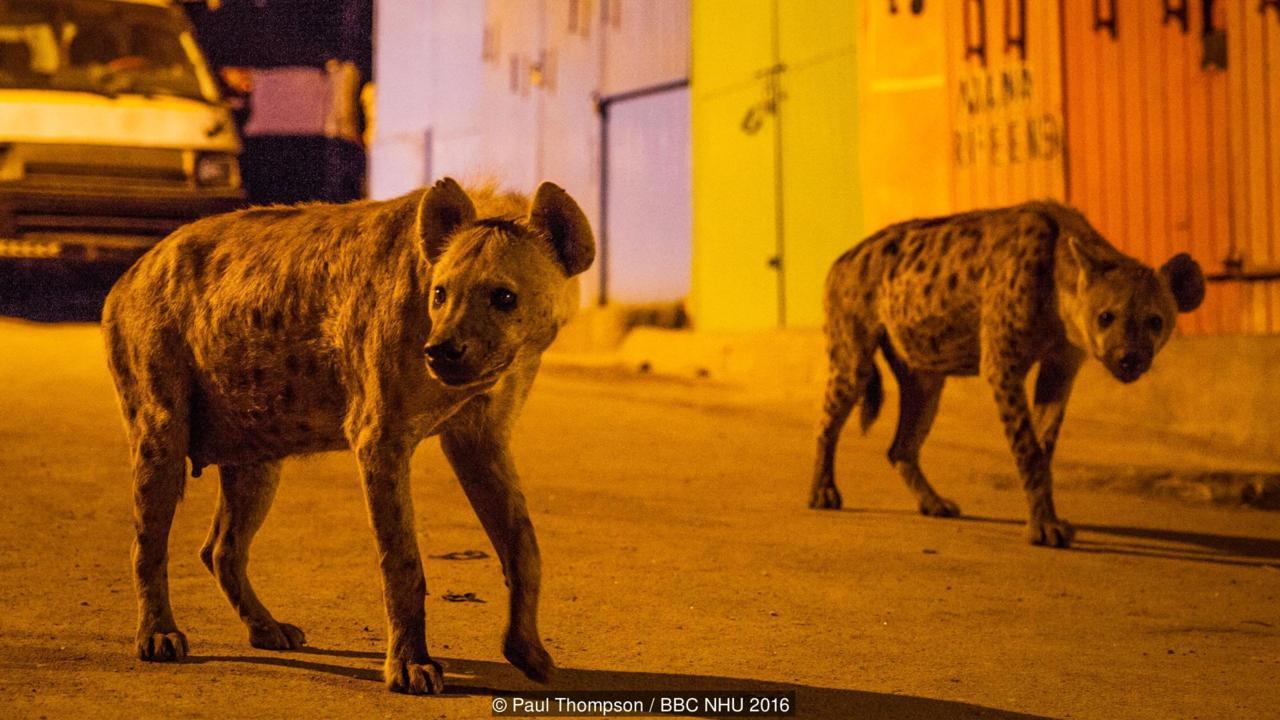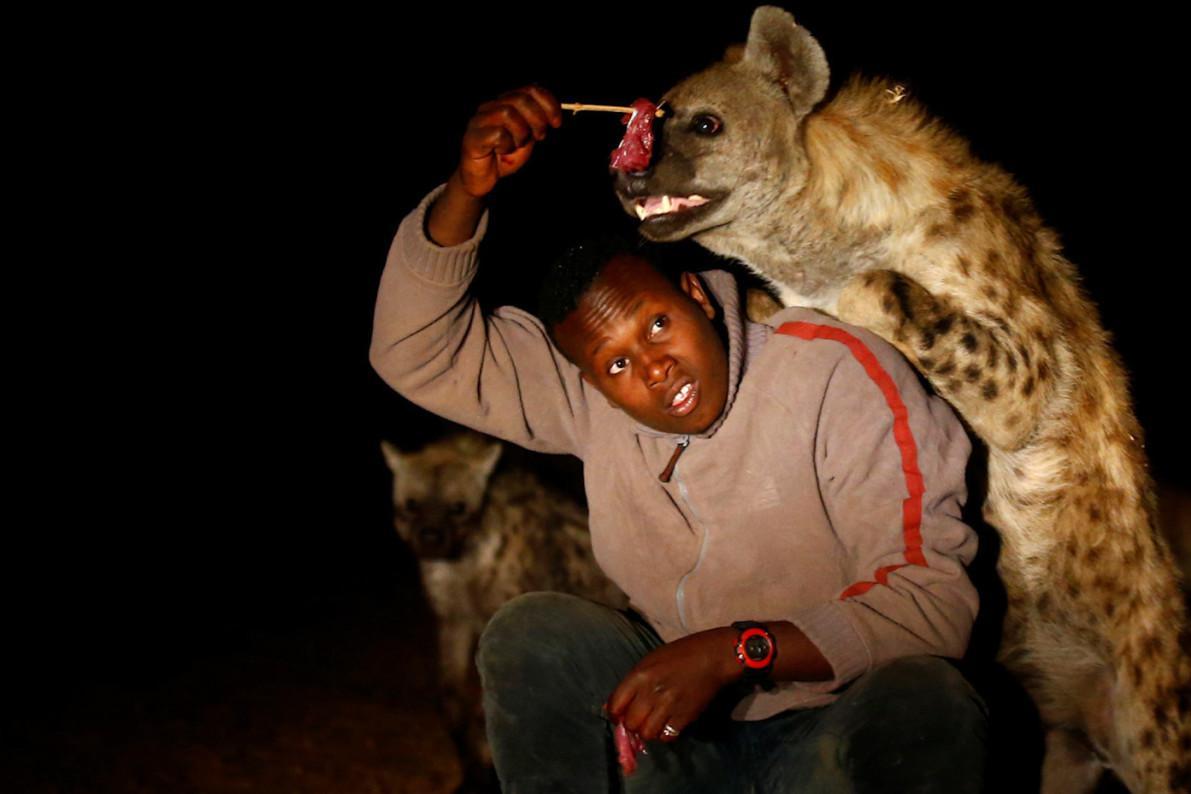The first image is the image on the left, the second image is the image on the right. Evaluate the accuracy of this statement regarding the images: "There are two hyenas in total.". Is it true? Answer yes or no. No. The first image is the image on the left, the second image is the image on the right. Examine the images to the left and right. Is the description "The left image contains a human interacting with a hyena." accurate? Answer yes or no. No. 